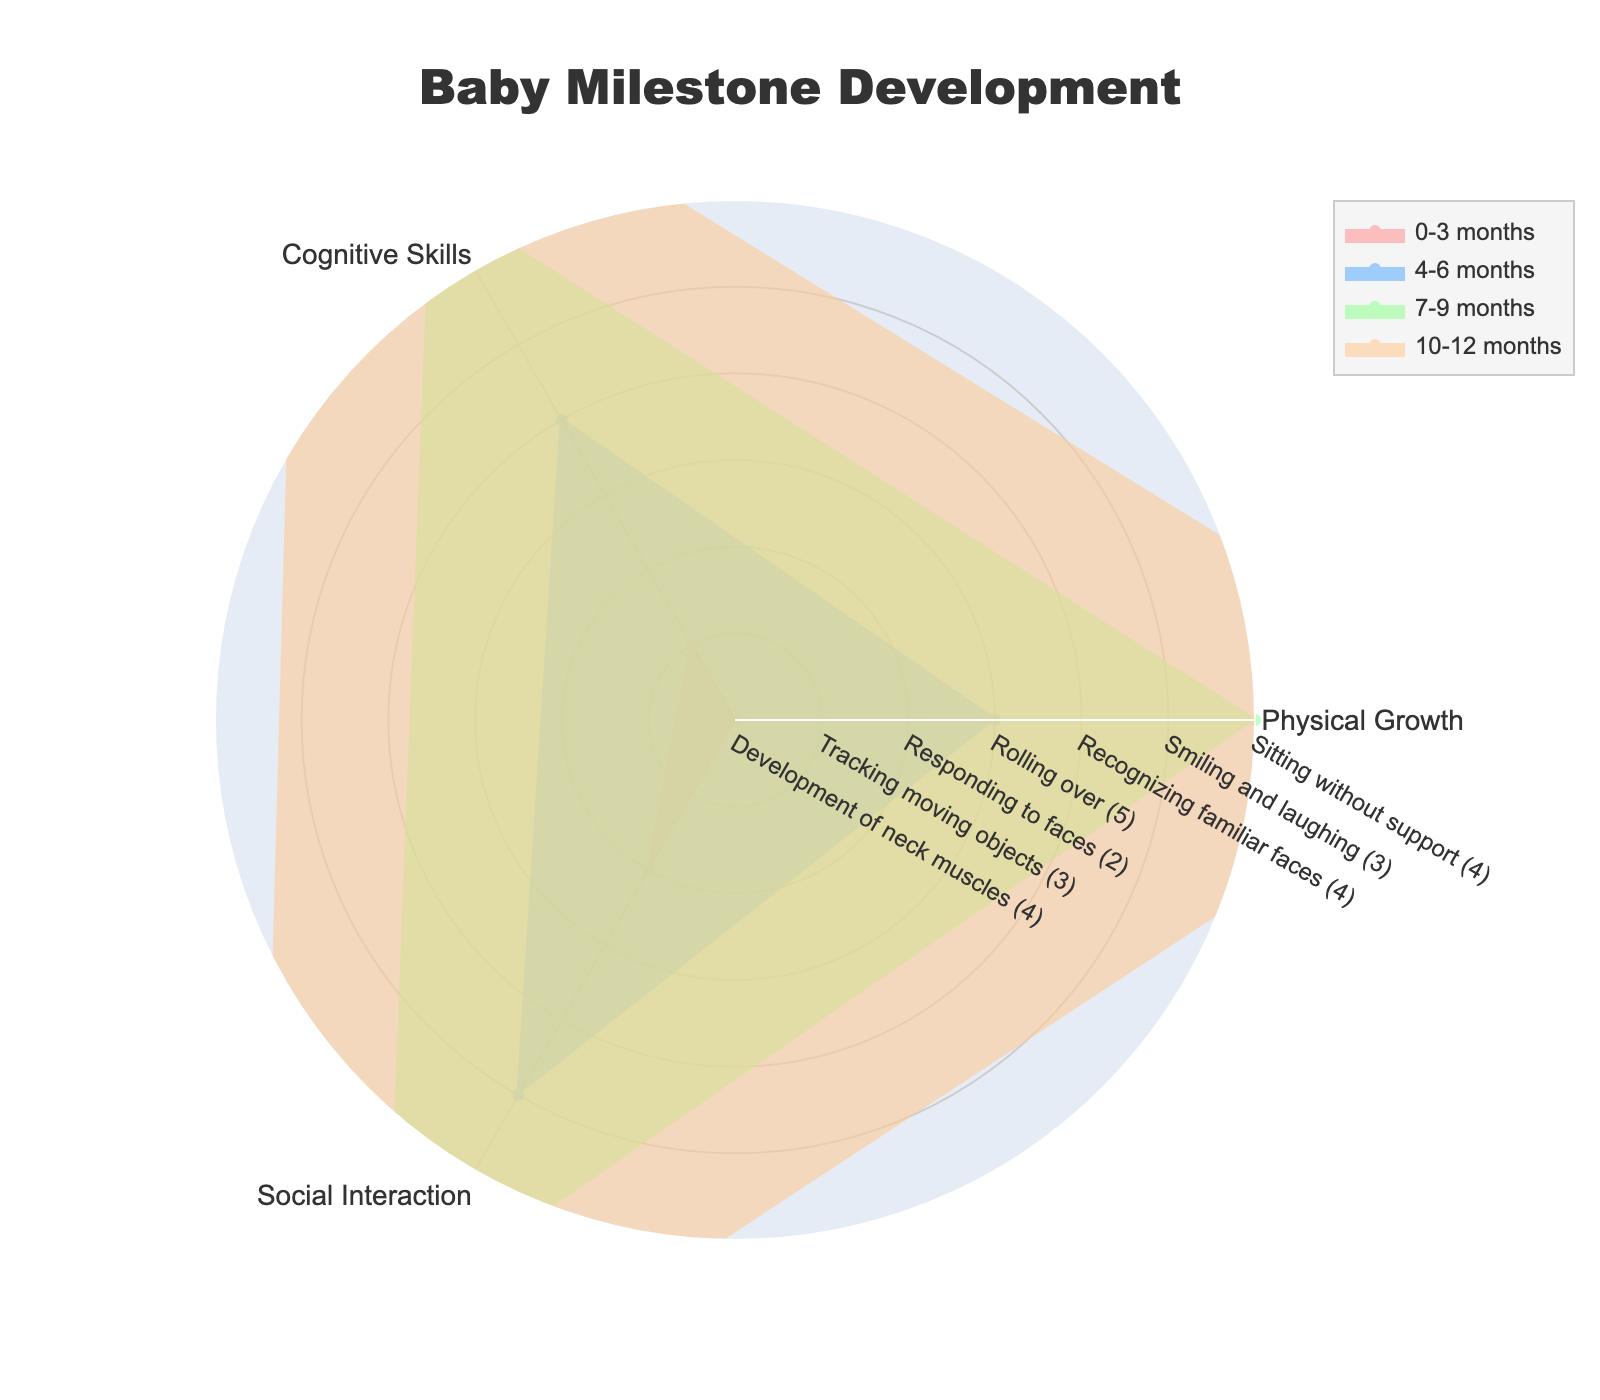What is the title of the radar chart? The title of the radar chart is prominently displayed at the top, indicating the main topic of the visual.
Answer: Baby Milestone Development What are the three categories shown on the radar chart? The radar chart highlights data across three main categories, which are listed around the chart.
Answer: Physical Growth, Cognitive Skills, Social Interaction Which age group shows the highest value for physical growth? By inspecting the radar chart and focusing on the "Physical Growth" axis, we can identify the age group with the highest score.
Answer: 4-6 months and 10-12 months What is the range of values displayed on the radial axis of the radar chart? The radial axis of a radar chart typically shows the scale of measurement used for the data points.
Answer: 0 to 6 Which age group has the lowest value for "Social Interaction"? Observe the "Social Interaction" axis and identify the age group with the smallest value on this axis.
Answer: 0-3 months Compare the cognitive skills between the 4-6 months and 7-9 months age groups. Which group shows higher cognitive development? By looking at the values on the "Cognitive Skills" axis for both age groups, we can determine which one is higher.
Answer: 7-9 months Calculate the average value of "Social Interaction" for all age groups. Add all the values for "Social Interaction" from each age group and divide by the number of age groups (2 + 3 + 4 + 5 = 14; 14/4 = 3.5).
Answer: 3.5 Which age group exhibits the greatest variation across all three categories? To determine this, compare the spread or differences among the values within each age group. The greater the differences, the higher the variation.
Answer: 10-12 months What is the difference in physical growth between the 0-3 months and the 10-12 months age groups? Subtract the physical growth value of the 0-3 months age group from that of the 10-12 months age group (5 - 4).
Answer: 1 Which age group shows the most balanced development across all three categories? To identify the most balanced development, look for the age group with the closest values among "Physical Growth," "Cognitive Skills," and "Social Interaction."
Answer: 7-9 months 